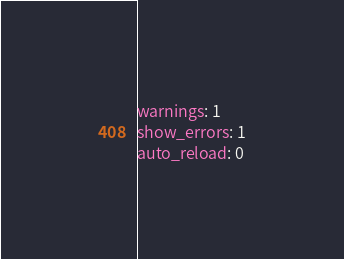Convert code to text. <code><loc_0><loc_0><loc_500><loc_500><_YAML_>warnings: 1
show_errors: 1
auto_reload: 0
</code> 